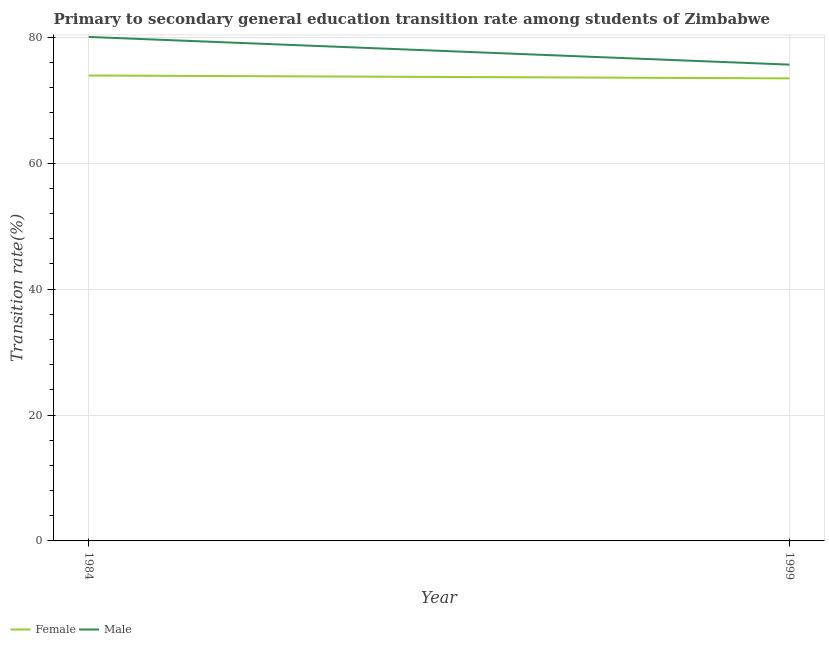How many different coloured lines are there?
Your response must be concise. 2. What is the transition rate among female students in 1984?
Ensure brevity in your answer.  73.93. Across all years, what is the maximum transition rate among female students?
Offer a very short reply. 73.93. Across all years, what is the minimum transition rate among female students?
Keep it short and to the point. 73.48. In which year was the transition rate among female students minimum?
Make the answer very short. 1999. What is the total transition rate among male students in the graph?
Offer a very short reply. 155.72. What is the difference between the transition rate among male students in 1984 and that in 1999?
Ensure brevity in your answer.  4.4. What is the difference between the transition rate among female students in 1984 and the transition rate among male students in 1999?
Offer a terse response. -1.73. What is the average transition rate among male students per year?
Ensure brevity in your answer.  77.86. In the year 1984, what is the difference between the transition rate among female students and transition rate among male students?
Make the answer very short. -6.13. In how many years, is the transition rate among female students greater than 44 %?
Offer a terse response. 2. What is the ratio of the transition rate among female students in 1984 to that in 1999?
Your answer should be compact. 1.01. Is the transition rate among female students in 1984 less than that in 1999?
Give a very brief answer. No. What is the difference between two consecutive major ticks on the Y-axis?
Your answer should be very brief. 20. Are the values on the major ticks of Y-axis written in scientific E-notation?
Offer a terse response. No. Where does the legend appear in the graph?
Offer a terse response. Bottom left. What is the title of the graph?
Provide a succinct answer. Primary to secondary general education transition rate among students of Zimbabwe. What is the label or title of the X-axis?
Give a very brief answer. Year. What is the label or title of the Y-axis?
Provide a succinct answer. Transition rate(%). What is the Transition rate(%) in Female in 1984?
Provide a succinct answer. 73.93. What is the Transition rate(%) in Male in 1984?
Offer a terse response. 80.06. What is the Transition rate(%) of Female in 1999?
Offer a terse response. 73.48. What is the Transition rate(%) of Male in 1999?
Your answer should be very brief. 75.66. Across all years, what is the maximum Transition rate(%) in Female?
Provide a short and direct response. 73.93. Across all years, what is the maximum Transition rate(%) in Male?
Your answer should be very brief. 80.06. Across all years, what is the minimum Transition rate(%) of Female?
Provide a short and direct response. 73.48. Across all years, what is the minimum Transition rate(%) in Male?
Your response must be concise. 75.66. What is the total Transition rate(%) of Female in the graph?
Your response must be concise. 147.41. What is the total Transition rate(%) in Male in the graph?
Give a very brief answer. 155.72. What is the difference between the Transition rate(%) in Female in 1984 and that in 1999?
Provide a short and direct response. 0.46. What is the difference between the Transition rate(%) in Male in 1984 and that in 1999?
Your answer should be compact. 4.4. What is the difference between the Transition rate(%) of Female in 1984 and the Transition rate(%) of Male in 1999?
Your response must be concise. -1.73. What is the average Transition rate(%) in Female per year?
Keep it short and to the point. 73.7. What is the average Transition rate(%) in Male per year?
Give a very brief answer. 77.86. In the year 1984, what is the difference between the Transition rate(%) in Female and Transition rate(%) in Male?
Make the answer very short. -6.13. In the year 1999, what is the difference between the Transition rate(%) in Female and Transition rate(%) in Male?
Your answer should be compact. -2.18. What is the ratio of the Transition rate(%) of Female in 1984 to that in 1999?
Offer a terse response. 1.01. What is the ratio of the Transition rate(%) in Male in 1984 to that in 1999?
Provide a short and direct response. 1.06. What is the difference between the highest and the second highest Transition rate(%) in Female?
Make the answer very short. 0.46. What is the difference between the highest and the second highest Transition rate(%) in Male?
Your answer should be compact. 4.4. What is the difference between the highest and the lowest Transition rate(%) in Female?
Provide a short and direct response. 0.46. What is the difference between the highest and the lowest Transition rate(%) of Male?
Offer a very short reply. 4.4. 